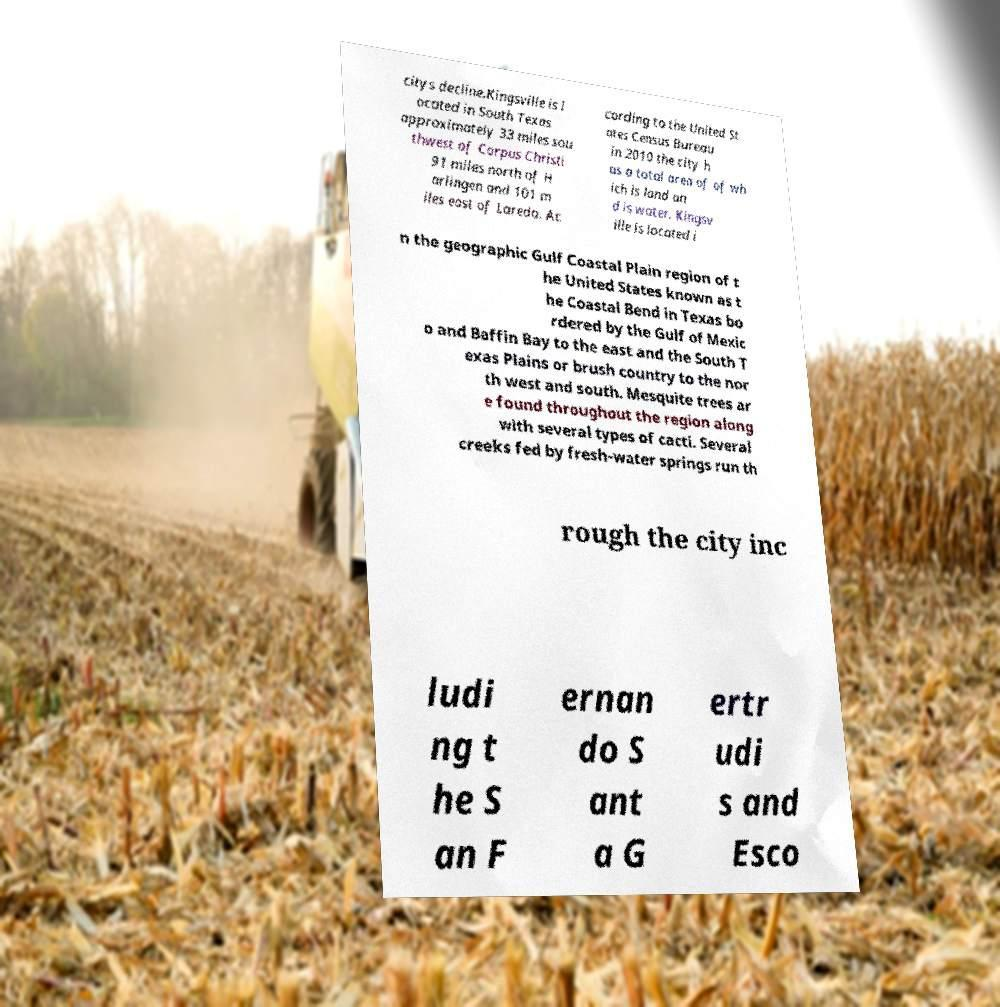Could you assist in decoding the text presented in this image and type it out clearly? citys decline.Kingsville is l ocated in South Texas approximately 33 miles sou thwest of Corpus Christi 91 miles north of H arlingen and 101 m iles east of Laredo. Ac cording to the United St ates Census Bureau in 2010 the city h as a total area of of wh ich is land an d is water. Kingsv ille is located i n the geographic Gulf Coastal Plain region of t he United States known as t he Coastal Bend in Texas bo rdered by the Gulf of Mexic o and Baffin Bay to the east and the South T exas Plains or brush country to the nor th west and south. Mesquite trees ar e found throughout the region along with several types of cacti. Several creeks fed by fresh-water springs run th rough the city inc ludi ng t he S an F ernan do S ant a G ertr udi s and Esco 